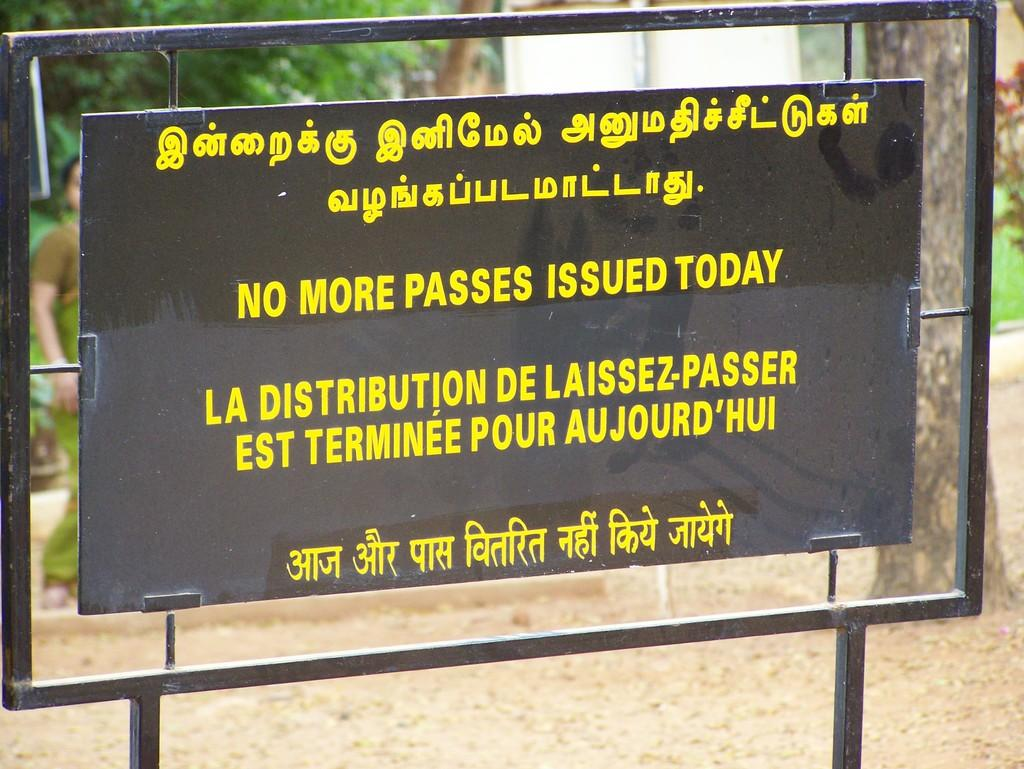What is the main object in the image? There is a board in the image. What can be found on the board? The board contains text in different languages. What can be seen in the background of the image? There are trees, a person, another board, and a tree trunk in the background of the image. What is visible on the ground in the image? The ground is visible in the image. What type of fish can be seen swimming in the vest in the image? There is no fish or vest present in the image. 